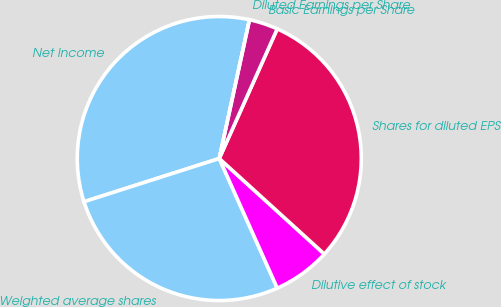Convert chart to OTSL. <chart><loc_0><loc_0><loc_500><loc_500><pie_chart><fcel>Net Income<fcel>Weighted average shares<fcel>Dilutive effect of stock<fcel>Shares for diluted EPS<fcel>Basic Earnings per Share<fcel>Diluted Earnings per Share<nl><fcel>33.33%<fcel>26.77%<fcel>6.56%<fcel>30.05%<fcel>3.28%<fcel>0.0%<nl></chart> 